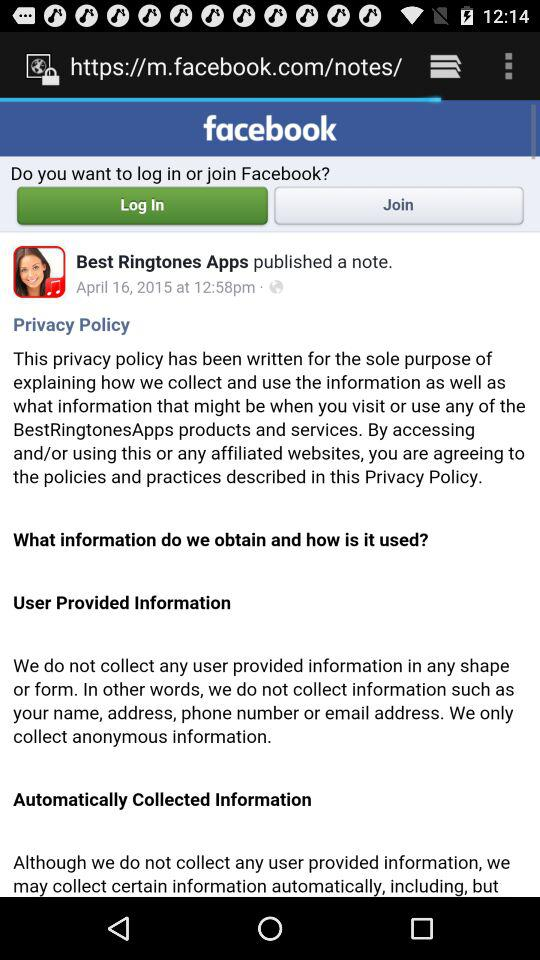What is the time of publication of the note? The time of publication of the note is 12:58 p.m. 